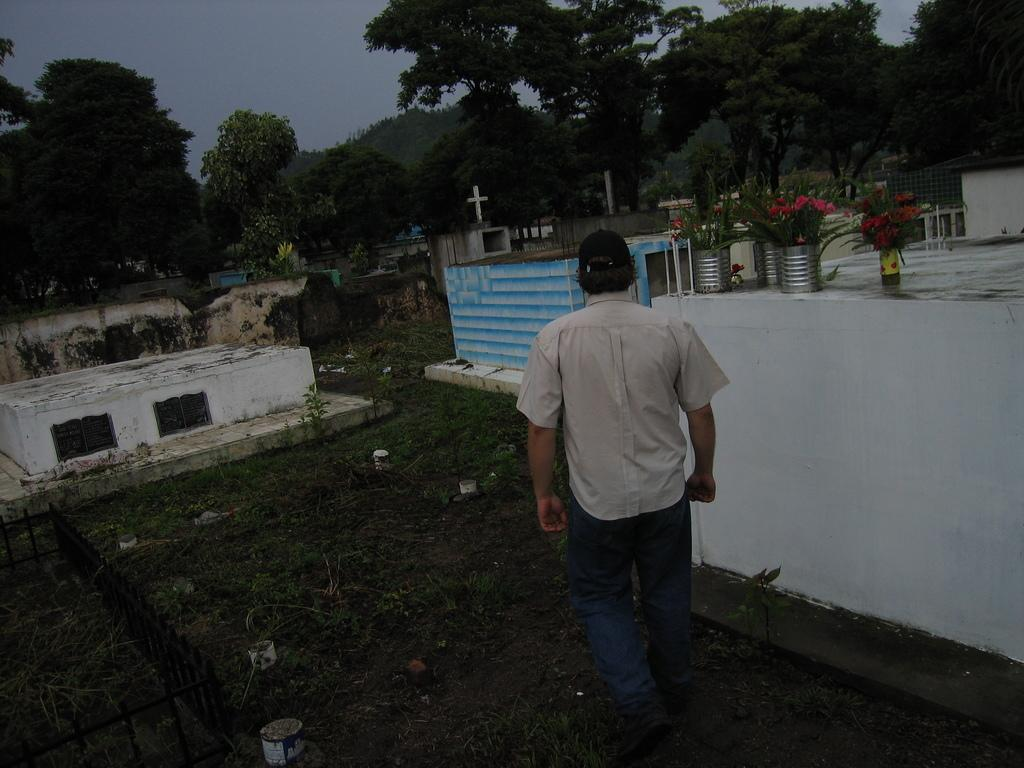Who is present in the image? There is a man in the image. What is the man doing in the image? The man is walking in a graveyard. What can be seen in the graveyard besides the man? There are graves in the image. What is visible in the background of the image? There are trees and the sky visible in the background of the image. What type of poison is the man holding in his finger in the image? There is no poison or finger present in the image; the man is simply walking in a graveyard. 